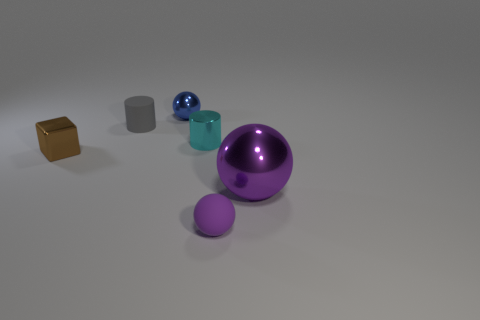Add 4 tiny blue things. How many objects exist? 10 Subtract all gray cylinders. How many cylinders are left? 1 Subtract all tiny spheres. How many spheres are left? 1 Add 1 large gray cylinders. How many large gray cylinders exist? 1 Subtract 0 cyan balls. How many objects are left? 6 Subtract all cubes. How many objects are left? 5 Subtract 1 blocks. How many blocks are left? 0 Subtract all gray balls. Subtract all gray blocks. How many balls are left? 3 Subtract all purple spheres. How many blue cubes are left? 0 Subtract all tiny blocks. Subtract all matte objects. How many objects are left? 3 